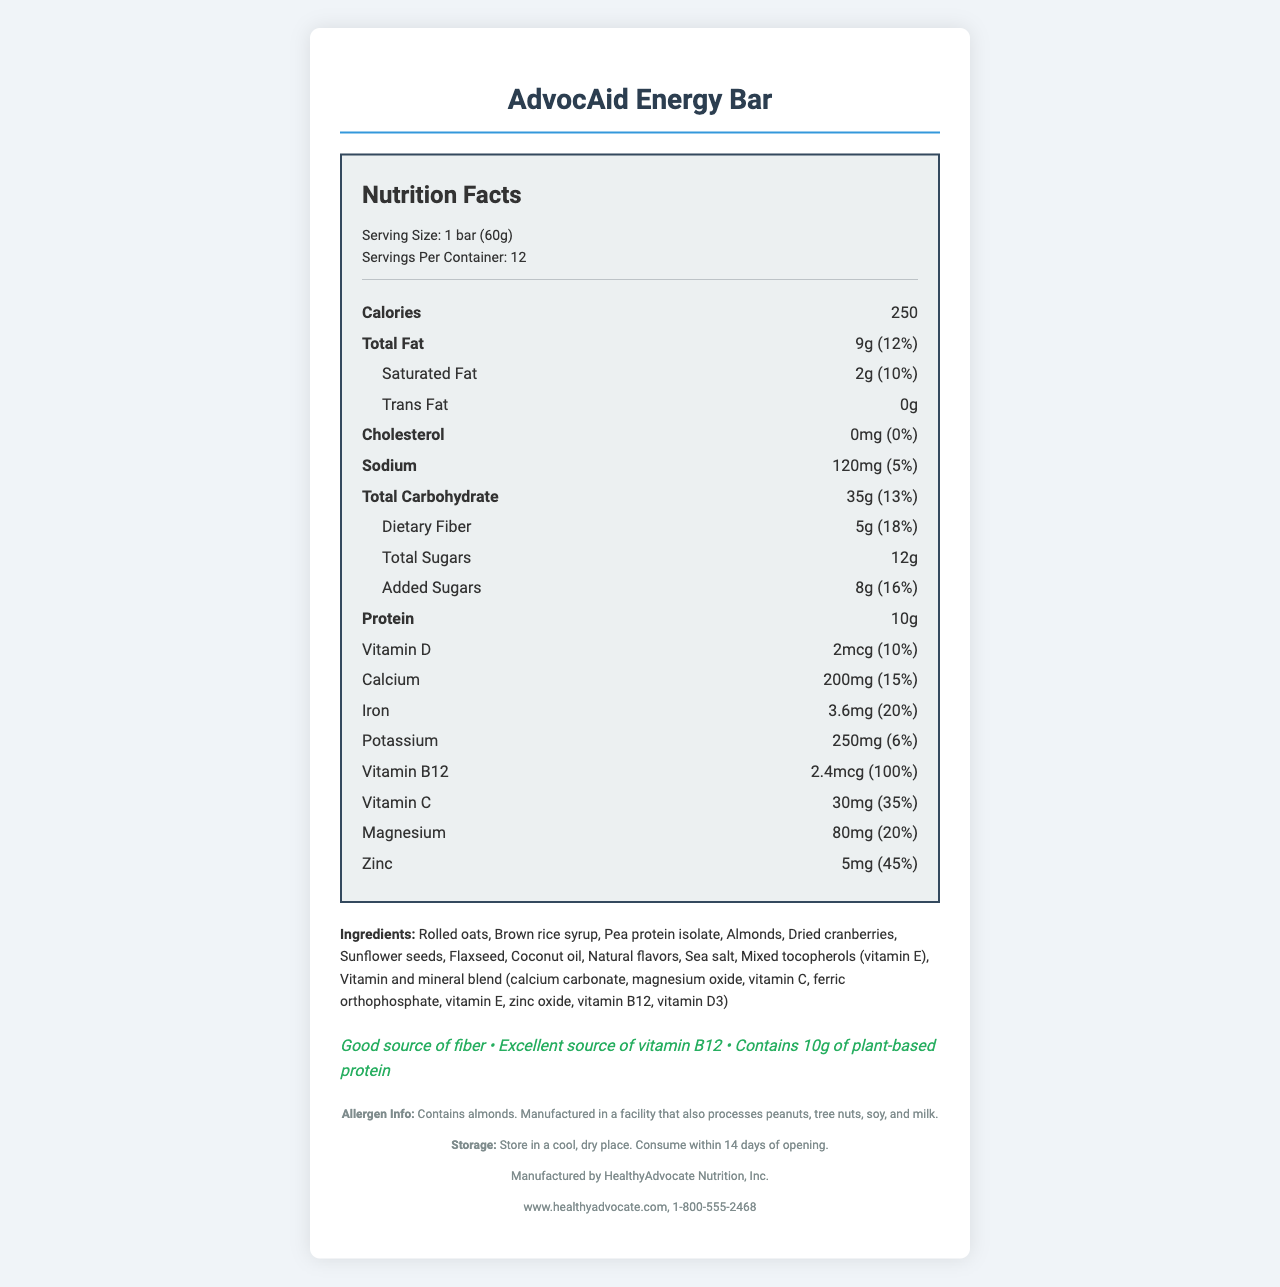what is the serving size for the AdvocAid Energy Bar? The serving size is listed as "1 bar (60g)" under the serving information.
Answer: 1 bar (60g) how many calories are in one serving of the AdvocAid Energy Bar? The document indicates there are 250 calories per serving.
Answer: 250 how much protein does one AdvocAid Energy Bar contain? The protein content is listed as 10g in the nutrition label.
Answer: 10g how much dietary fiber is in one serving? The dietary fiber amount is 5g per serving.
Answer: 5g which vitamin has the highest daily value percentage in the AdvocAid Energy Bar? Vitamin B12 has a daily value of 100%, which is the highest listed among the vitamins and minerals.
Answer: Vitamin B12 does this energy bar contain any trans fat? The trans fat content is listed as 0g, indicating that the product does not contain any trans fat.
Answer: No how much calcium does one serving of AdvocAid Energy Bar provide? A. 100mg B. 150mg C. 200mg D. 250mg The calcium content listed is "200mg" per serving.
Answer: C. 200mg which of the following is a health claim made about the AdvocAid Energy Bar? I. Good source of fiber II. Low in Sodium III. Contains 10g of plant-based protein The health claims listed are "Good source of fiber" and "Contains 10g of plant-based protein".
Answer: I and III is the AdvocAid Energy Bar a good source of vitamin C? The bar provides 30mg of Vitamin C, which is 35% of the daily value, meeting the criteria to be considered a good source.
Answer: Yes what allergens are present in the AdvocAid Energy Bar? The allergen information section indicates the bar contains almonds and is processed in a facility that handles peanuts, tree nuts, soy, and milk.
Answer: Almonds summarize the information provided in the AdvocAid Energy Bar nutrition facts label. The document includes comprehensive details on the nutritional content of the AdvocAid Energy Bar, health claims, ingredient list, and allergen information, providing a well-rounded summary of what the product offers.
Answer: The label provides detailed nutritional information for the AdvocAid Energy Bar, including serving size, calories, macronutrient content such as fats, carbohydrates, proteins, and detailed vitamin and mineral information. It highlights the bar’s high fiber and vitamin B12 content and its plant-based protein source, also specifying allergens and storage instructions. what is the manufacturer of the AdvocAid Energy Bar? The footer of the label specifies that the manufacturer is "HealthyAdvocate Nutrition, Inc."
Answer: HealthyAdvocate Nutrition, Inc. is the AdvocAid Energy Bar gluten-free? The document does not specify whether the product is gluten-free or not.
Answer: Not enough information who can consumers contact for more information about AdvocAid Energy Bar? Contact information for more details about the product is provided as "www.healthyadvocate.com, 1-800-555-2468".
Answer: www.healthyadvocate.com, 1-800-555-2468 